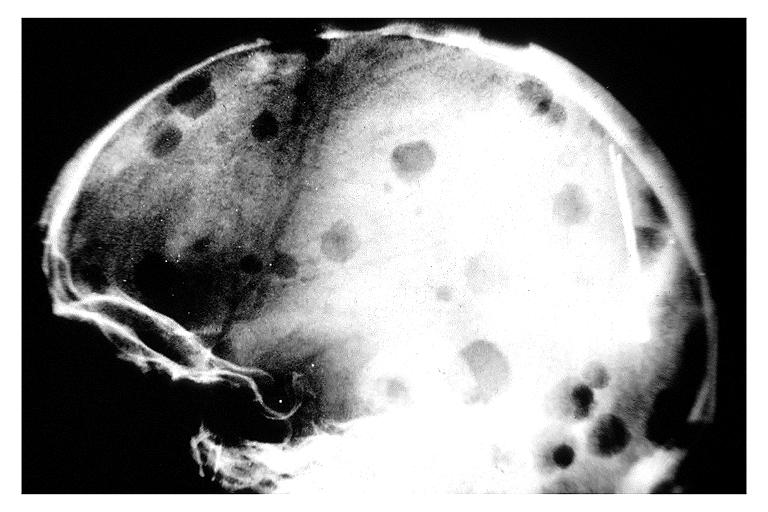does this image show multiple myeloma?
Answer the question using a single word or phrase. Yes 